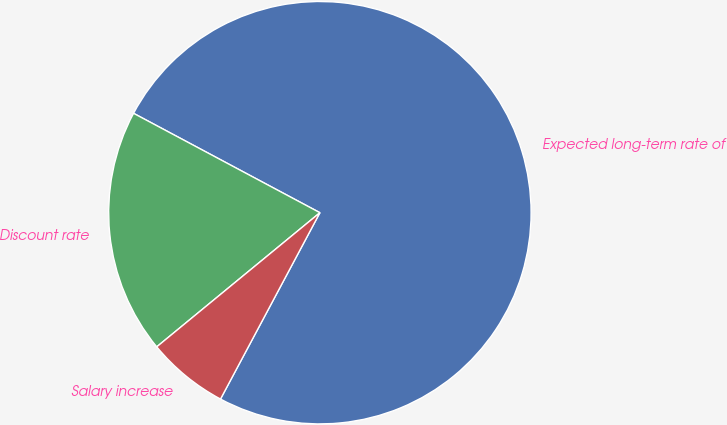<chart> <loc_0><loc_0><loc_500><loc_500><pie_chart><fcel>Expected long-term rate of<fcel>Discount rate<fcel>Salary increase<nl><fcel>75.0%<fcel>18.75%<fcel>6.25%<nl></chart> 